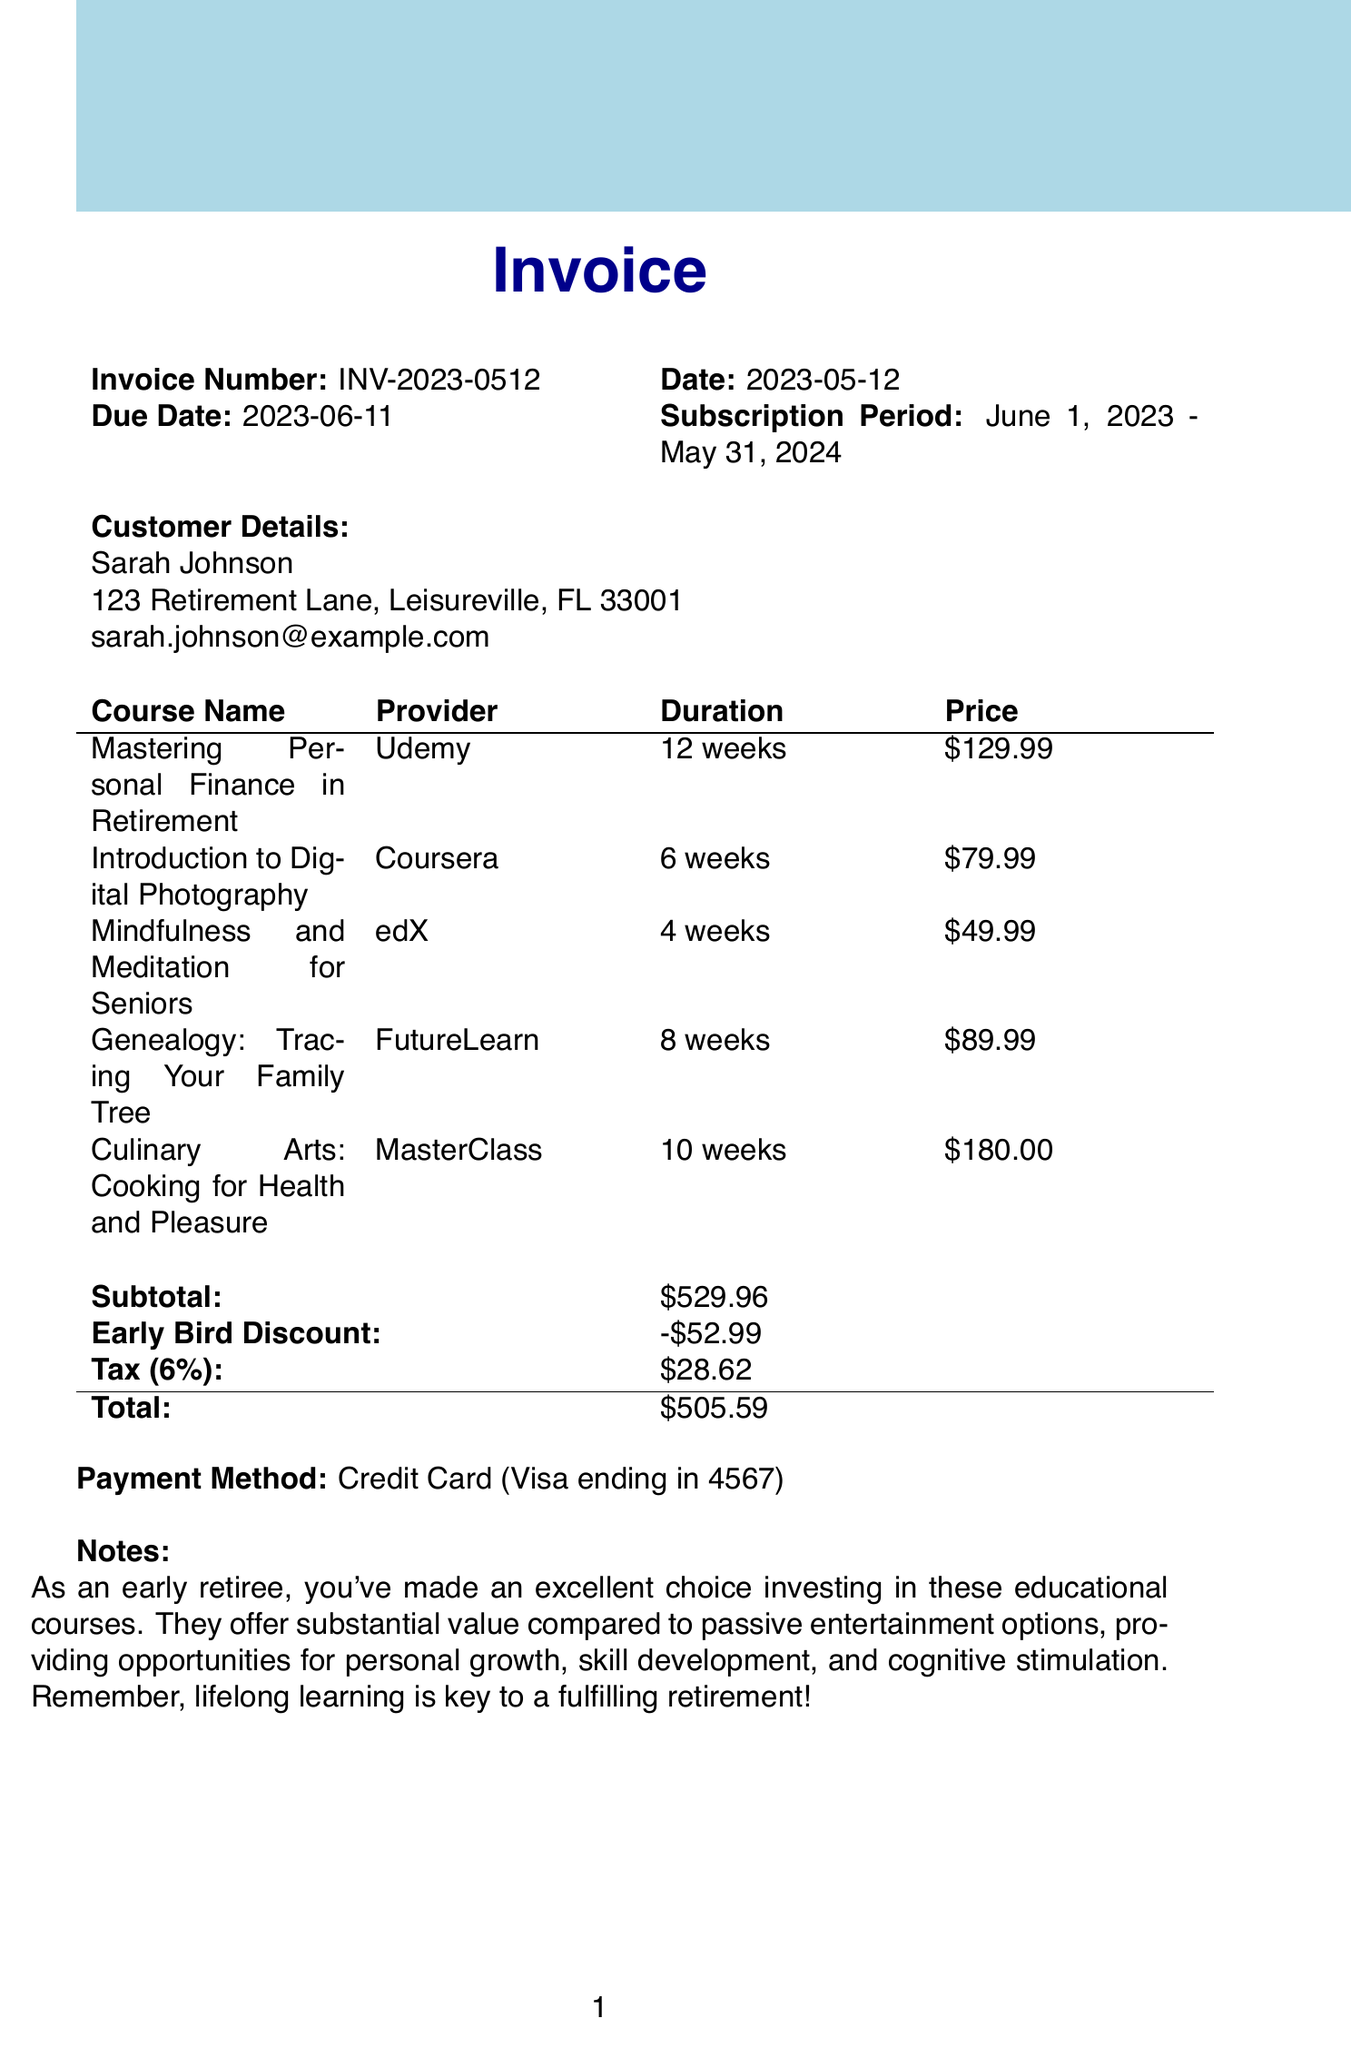What is the invoice number? The invoice number is specified clearly at the top of the document.
Answer: INV-2023-0512 What is the total amount due? The total amount is calculated at the end of the invoice after applying discounts and taxes.
Answer: $505.59 What is the name of the course offered by MasterClass? The course offered by MasterClass is listed in the courses section of the document.
Answer: Culinary Arts: Cooking for Health and Pleasure What is the duration of the "Mindfulness and Meditation for Seniors" course? The duration for this specific course is mentioned alongside its details.
Answer: 4 weeks Which discount is applied to the invoice? The discount section provides the name of the discount applied to the invoice total.
Answer: Early Bird Discount How much was the subtotal before the discount? The subtotal appears in the breakdown of costs before any discounts or taxes are added.
Answer: $529.96 What is the tax rate applied to the invoice? The tax rate is specified in the tax section of the invoice.
Answer: 6% What is the payment method used for this invoice? The payment method appears at the end, clearly specifying the type and last digits of the card used.
Answer: Credit Card (Visa ending in 4567) How long is the subscription period? The subscription period is mentioned in the header section of the document.
Answer: June 1, 2023 - May 31, 2024 What is the provider of the "Introduction to Digital Photography" course? The provider is listed next to the course name in the courses table.
Answer: Coursera 